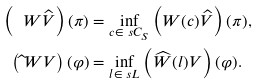Convert formula to latex. <formula><loc_0><loc_0><loc_500><loc_500>\left ( \ W \widehat { V } \right ) ( \pi ) & = \inf _ { c \in \ s C _ { S } } \left ( W ( c ) \widehat { V } \right ) ( \pi ) , \\ \left ( \widehat { \ } W V \right ) ( \varphi ) & = \inf _ { l \in \ s L } \left ( \widehat { W } ( l ) V \right ) ( \varphi ) .</formula> 